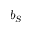<formula> <loc_0><loc_0><loc_500><loc_500>b _ { S }</formula> 